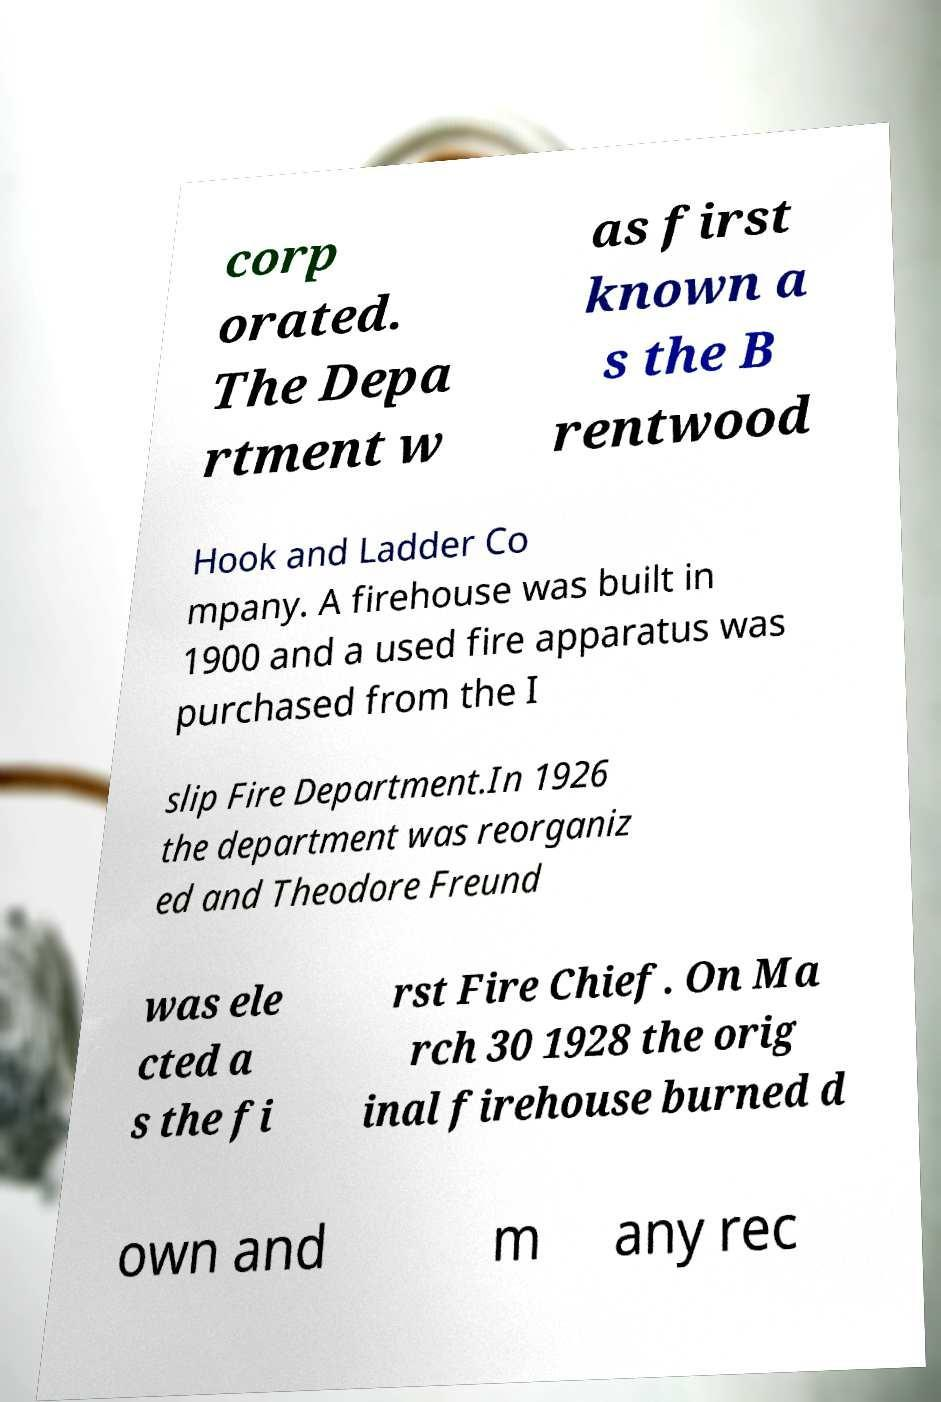Please read and relay the text visible in this image. What does it say? corp orated. The Depa rtment w as first known a s the B rentwood Hook and Ladder Co mpany. A firehouse was built in 1900 and a used fire apparatus was purchased from the I slip Fire Department.In 1926 the department was reorganiz ed and Theodore Freund was ele cted a s the fi rst Fire Chief. On Ma rch 30 1928 the orig inal firehouse burned d own and m any rec 